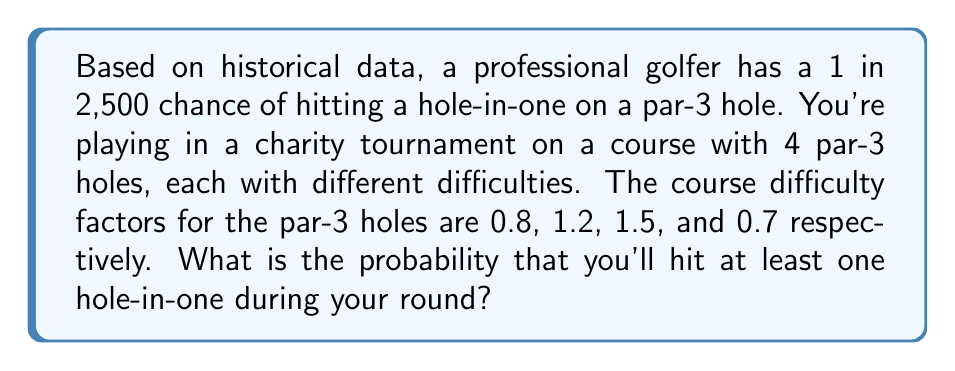Provide a solution to this math problem. Let's approach this step-by-step:

1) First, we need to calculate the probability of a hole-in-one for each par-3 hole, considering their difficulty factors:

   Hole 1: $P_1 = \frac{1}{2500} \times 0.8 = 0.00032$
   Hole 2: $P_2 = \frac{1}{2500} \times 1.2 = 0.00048$
   Hole 3: $P_3 = \frac{1}{2500} \times 1.5 = 0.0006$
   Hole 4: $P_4 = \frac{1}{2500} \times 0.7 = 0.00028$

2) Now, we need to calculate the probability of NOT getting a hole-in-one on each hole:

   $Q_1 = 1 - P_1 = 0.99968$
   $Q_2 = 1 - P_2 = 0.99952$
   $Q_3 = 1 - P_3 = 0.9994$
   $Q_4 = 1 - P_4 = 0.99972$

3) The probability of not getting any hole-in-one during the round is the product of these probabilities:

   $P(\text{no hole-in-one}) = Q_1 \times Q_2 \times Q_3 \times Q_4$
   $= 0.99968 \times 0.99952 \times 0.9994 \times 0.99972$
   $= 0.99832$

4) Therefore, the probability of getting at least one hole-in-one is:

   $P(\text{at least one hole-in-one}) = 1 - P(\text{no hole-in-one})$
   $= 1 - 0.99832$
   $= 0.00168$

5) Converting to a percentage:

   $0.00168 \times 100\% = 0.168\%$
Answer: 0.168% 